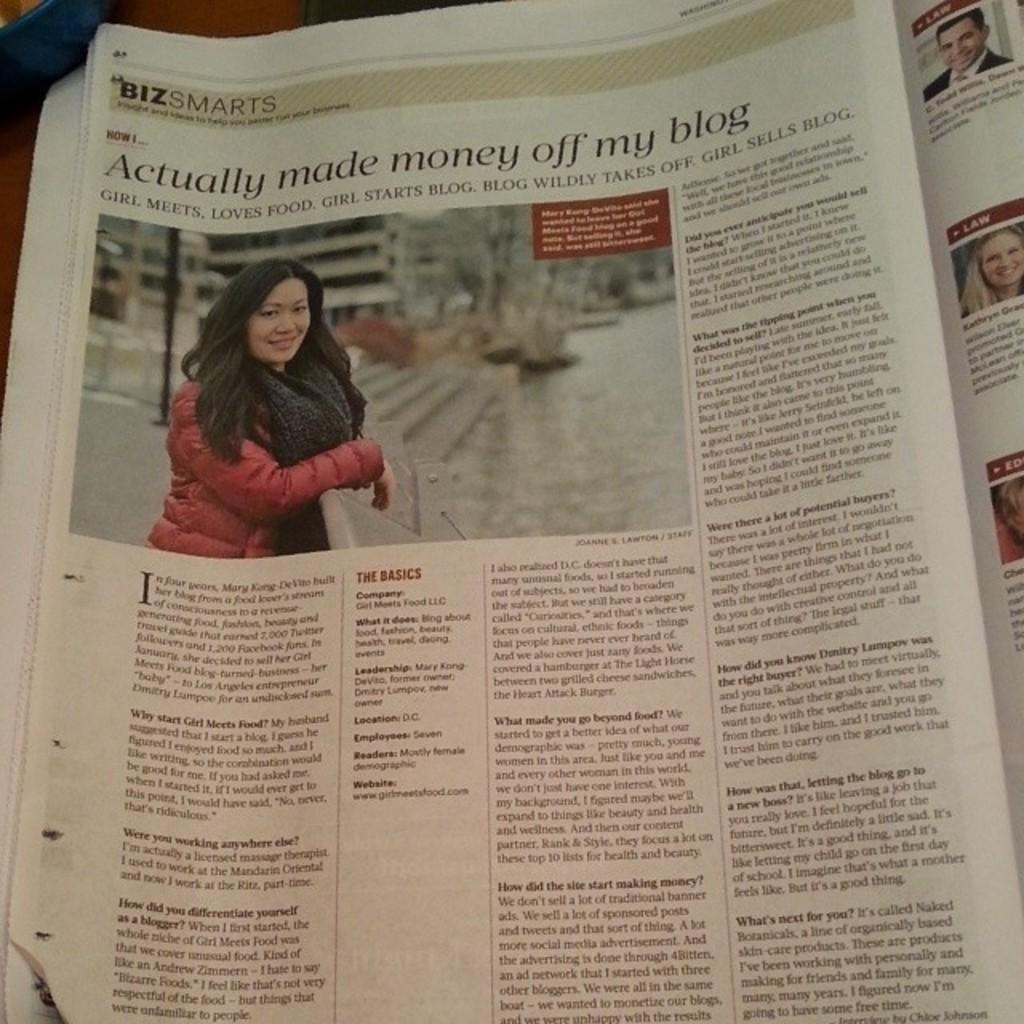What is the main object in the image? There is a newspaper in the image. What can be found within the newspaper? The newspaper contains images and words. Can you describe the blue object in the top left corner of the image? Unfortunately, there is no mention of a blue object in the top left corner of the image. What is the aftermath of the school thought in the image? There is no mention of a school or thought in the image, so it is not possible to determine the aftermath of such an event. 